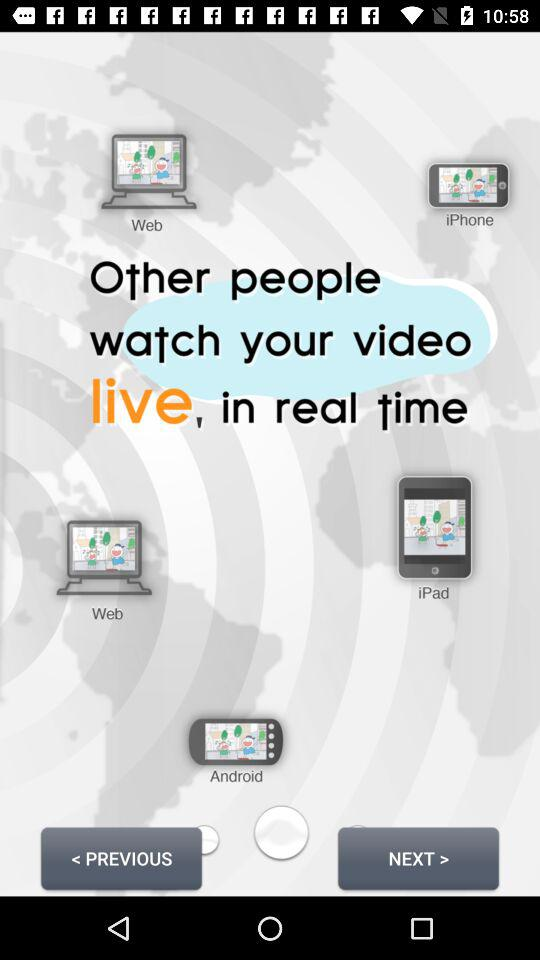How many platforms are there in total?
Answer the question using a single word or phrase. 4 